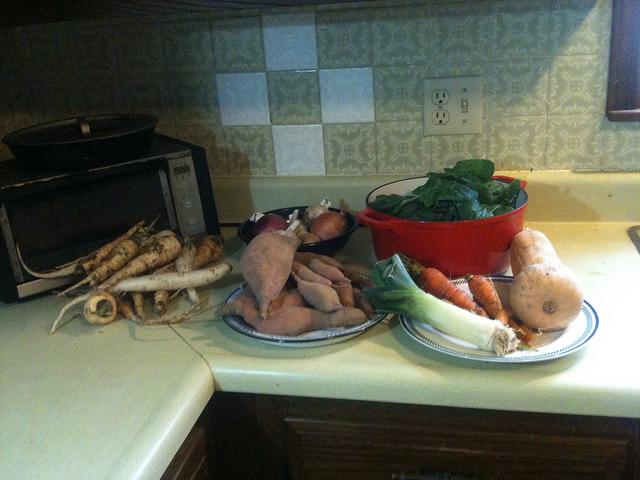Are these food items fruits?
Concise answer only. No. What color is the countertop?
Concise answer only. White. Is there carrots in this photo?
Answer briefly. Yes. 